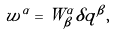Convert formula to latex. <formula><loc_0><loc_0><loc_500><loc_500>w ^ { \alpha } = W ^ { \alpha } _ { \beta } \delta q ^ { \beta } ,</formula> 